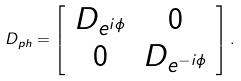Convert formula to latex. <formula><loc_0><loc_0><loc_500><loc_500>D _ { p h } = \left [ \begin{array} { c c } D _ { e ^ { i \phi } } & 0 \\ 0 & D _ { e ^ { - i \phi } } \end{array} \right ] .</formula> 